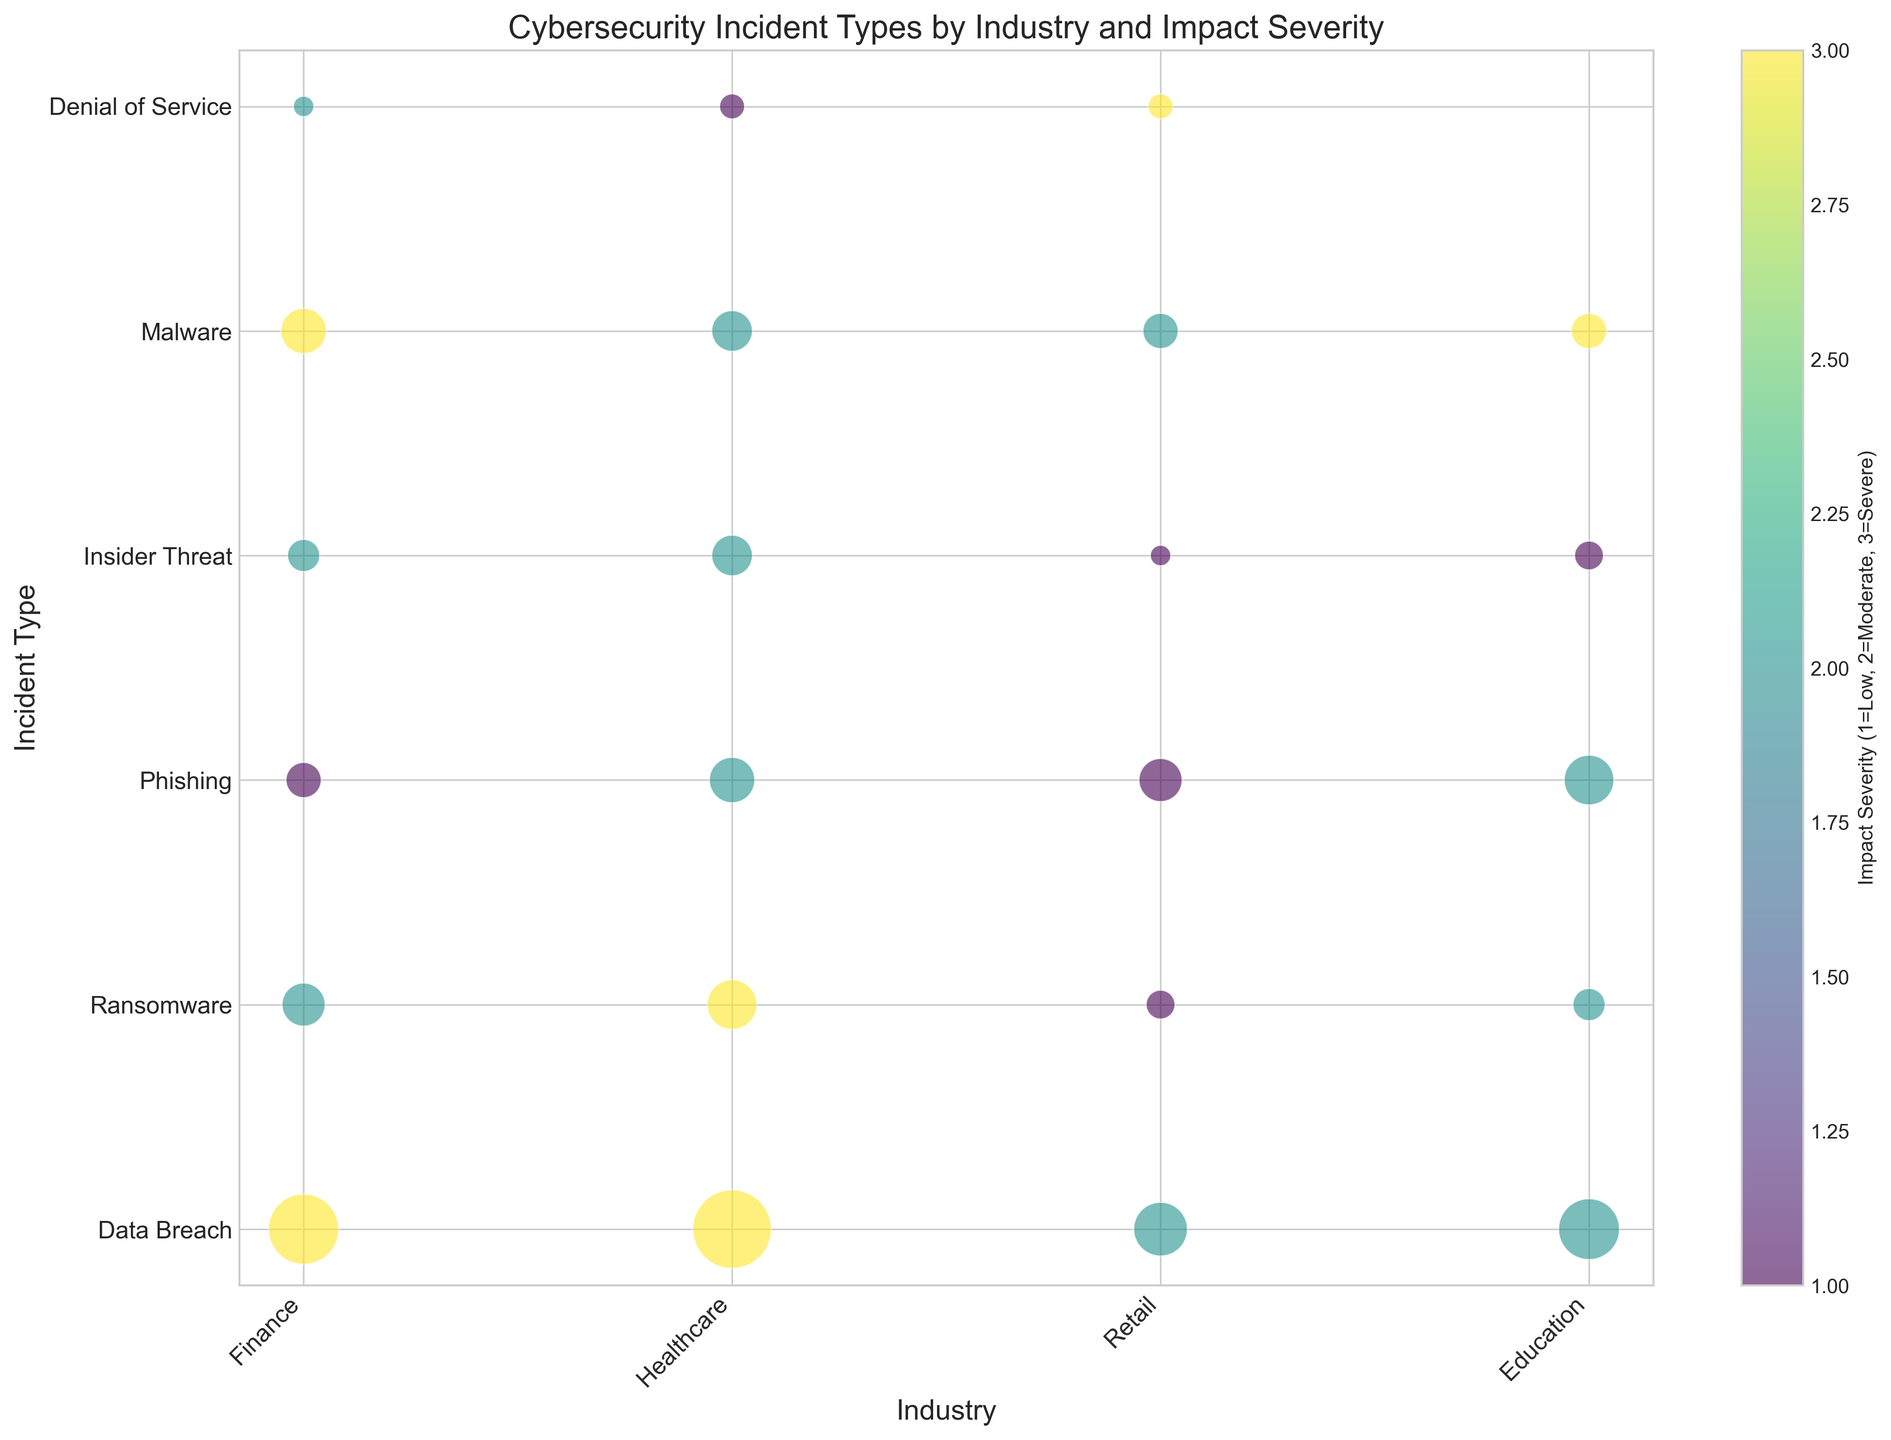Which industry has the most severe data breaches? Look for the largest bubbles labeled 'Data Breach' in the 'Severe' category. The largest bubble is found in the Healthcare industry.
Answer: Healthcare What is the total number of phishing incidents across all industries? Sum the number of incidents for 'Phishing' across all industries: Finance (30) + Healthcare (50) + Retail (45) + Education (60). Total is 30 + 50 + 45 + 60 = 185.
Answer: 185 Which incident type has the lowest impact severity in Retail? Identify the smallest bubbles in Retail and check their labels to find their impact severity. The smallest bubbles in Retail are 'Ransomware' and 'Insider Threat', both labeled as having 'Low' severity.
Answer: Ransomware, Insider Threat Which industry experiences the highest incidence of ransomware? Locate the largest bubbles labeled 'Ransomware' across industries. The largest bubble for 'Ransomware' is in the Healthcare industry.
Answer: Healthcare Compare the total number of severe incidents in Finance and Healthcare. Which industry has more? Sum the number of severe incidents in Finance (Data Breach 120 + Malware 50 = 170) and Healthcare (Data Breach 150 + Ransomware 60 + Malware 30 = 240). Healthcare has more.
Answer: Healthcare What's the average number of moderate impact severity incidents in Education? Identify and sum the moderate impact severity incidents in Education: (Phishing 60 + Ransomware 25 + Data Breach 90 + Insider Threat 20). Total is 60 + 25 + 90 + 20 = 195. Average is 195 / 4 = 48.75.
Answer: 48.75 How many total incidents are there in the Retail industry? Sum all incidents in the Retail industry across all impact severities and types: Data Breach (70), Ransomware (20), Phishing (45), Denial of Service (15), Insider Threat (10), and Malware (30). Total is 70 + 20 + 45 + 15 + 10 + 30 = 190.
Answer: 190 Which incident type affects Education with severe impact, and how many incidents are there? Look for the bubble in the Education industry that is labeled with severe impact severity. The incident type is 'Malware' with 30 incidents.
Answer: Malware, 30 Is the total number of insider threat incidents higher in Healthcare or Retail? Sum insider threat incidents in each industry: Healthcare (40) and Retail (10). Healthcare has a higher total.
Answer: Healthcare 